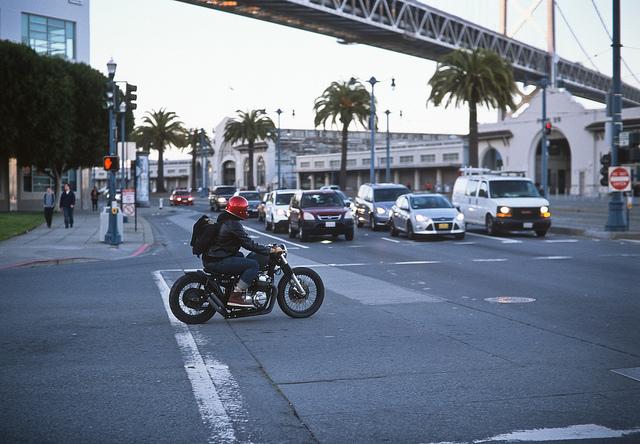How many motorcycles are there?
Concise answer only. 1. What time of day is it?
Quick response, please. Afternoon. What is the circle in the middle of the road called?
Be succinct. Manhole. What is this man riding?
Be succinct. Motorcycle. 